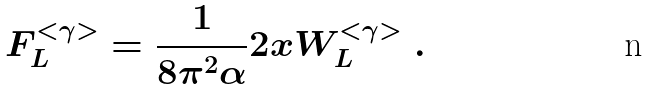Convert formula to latex. <formula><loc_0><loc_0><loc_500><loc_500>F _ { L } ^ { < \gamma > } = \frac { 1 } { 8 \pi ^ { 2 } \alpha } 2 x W _ { L } ^ { < \gamma > } \ .</formula> 